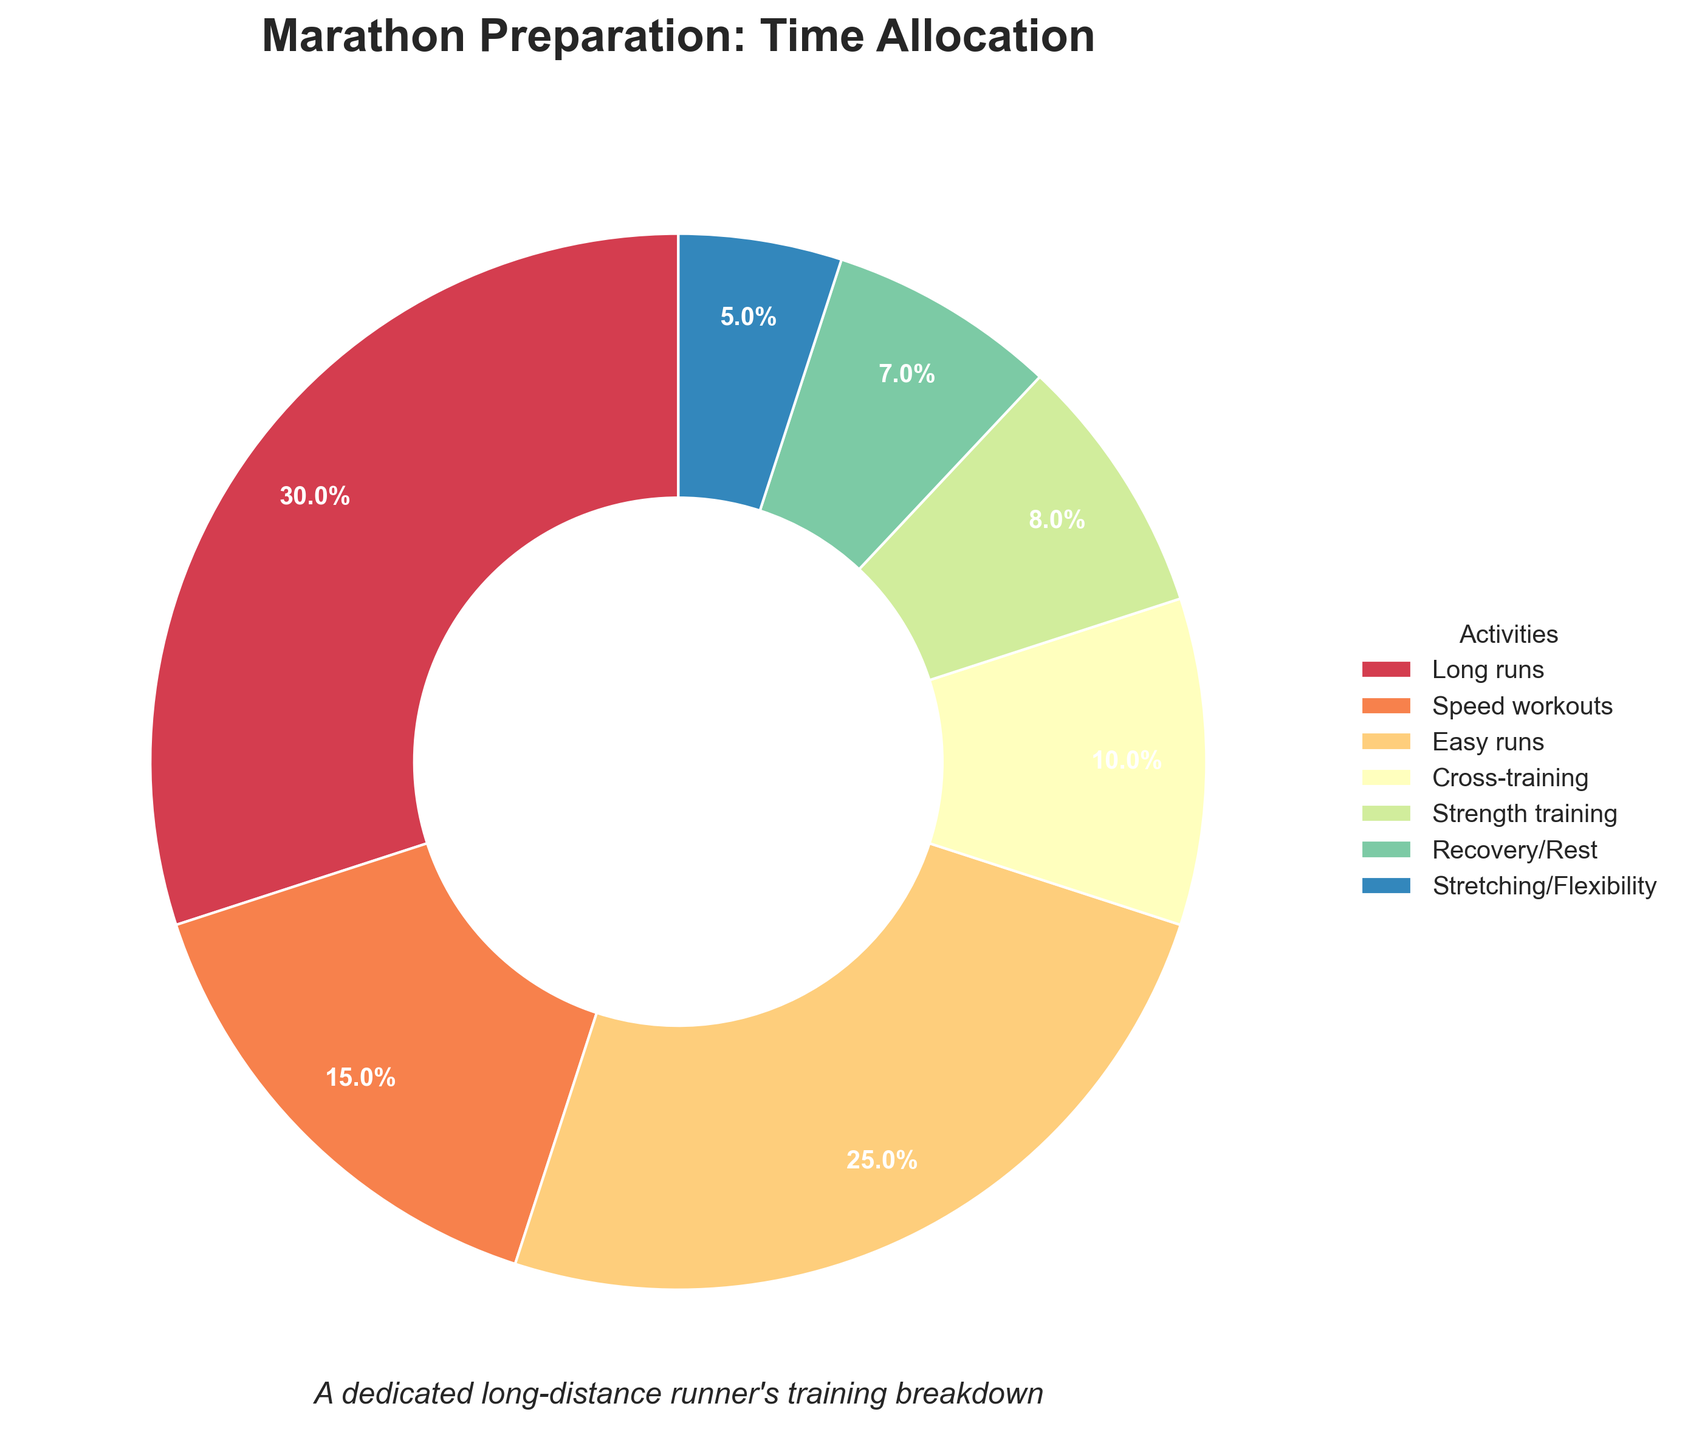What activity occupies the largest percentage of training? The pie chart shows that "Long runs" take up the biggest section of the chart. By glancing at the figures represented, "Long runs" is labeled with 30%.
Answer: Long runs What is the combined percentage of time spent on Cross-training and Strength training? Referring to the figures shown, Cross-training has 10% and Strength training has 8%. Summing them together gives 10% + 8% = 18%.
Answer: 18% Which activity has a greater allocation, Speed workouts or Easy runs? And by how much? Speed workouts have 15% and Easy runs have 25%, as displayed in the pie chart. Therefore, the percentage difference is 25% - 15% = 10%.
Answer: Easy runs by 10% Is the percentage of time spent on Recovery/Rest more or less than Stretching/Flexibility? The chart shows that Recovery/Rest has 7% while Stretching/Flexibility has 5%. Thus, Recovery/Rest is more.
Answer: More What is the total percentage of time dedicated to training activities excluding Long runs and Easy runs? Adding up the percentages of Speed workouts, Cross-training, Strength training, Recovery/Rest, and Stretching/Flexibility: 15% + 10% + 8% + 7% + 5% = 45%.
Answer: 45% Among the activities, which has the smallest percentage allocation? The chart labels indicate that "Stretching/Flexibility" has the smallest slice allocated to it at 5%.
Answer: Stretching/Flexibility What fraction of the total training is spent on both Speed workouts and Easy runs together? Adding the percentages of Speed workouts (15%) and Easy runs (25%) gives 15% + 25% = 40%.
Answer: 40% How does the percentage time for Strength training compare with Recovery/Rest? From the pie chart, Strength training has 8% while Recovery/Rest has 7%. Strength training is 1% higher than Recovery/Rest.
Answer: 1% higher Which activities together make up more than half of the total training time? Looking at the larger slices, Long runs (30%) and Easy runs (25%) together make up 30% + 25% = 55% of the total time.
Answer: Long runs and Easy runs 